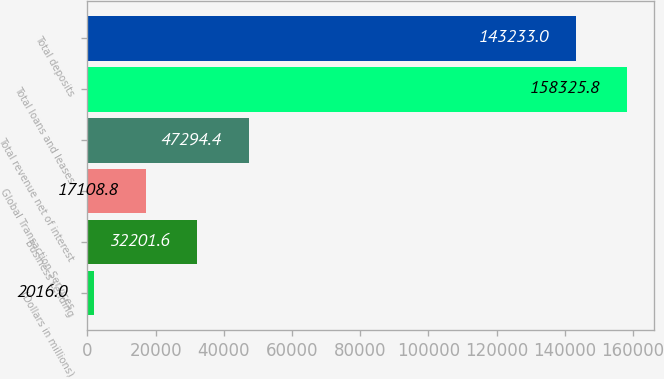Convert chart to OTSL. <chart><loc_0><loc_0><loc_500><loc_500><bar_chart><fcel>(Dollars in millions)<fcel>Business Lending<fcel>Global Transaction Services<fcel>Total revenue net of interest<fcel>Total loans and leases<fcel>Total deposits<nl><fcel>2016<fcel>32201.6<fcel>17108.8<fcel>47294.4<fcel>158326<fcel>143233<nl></chart> 